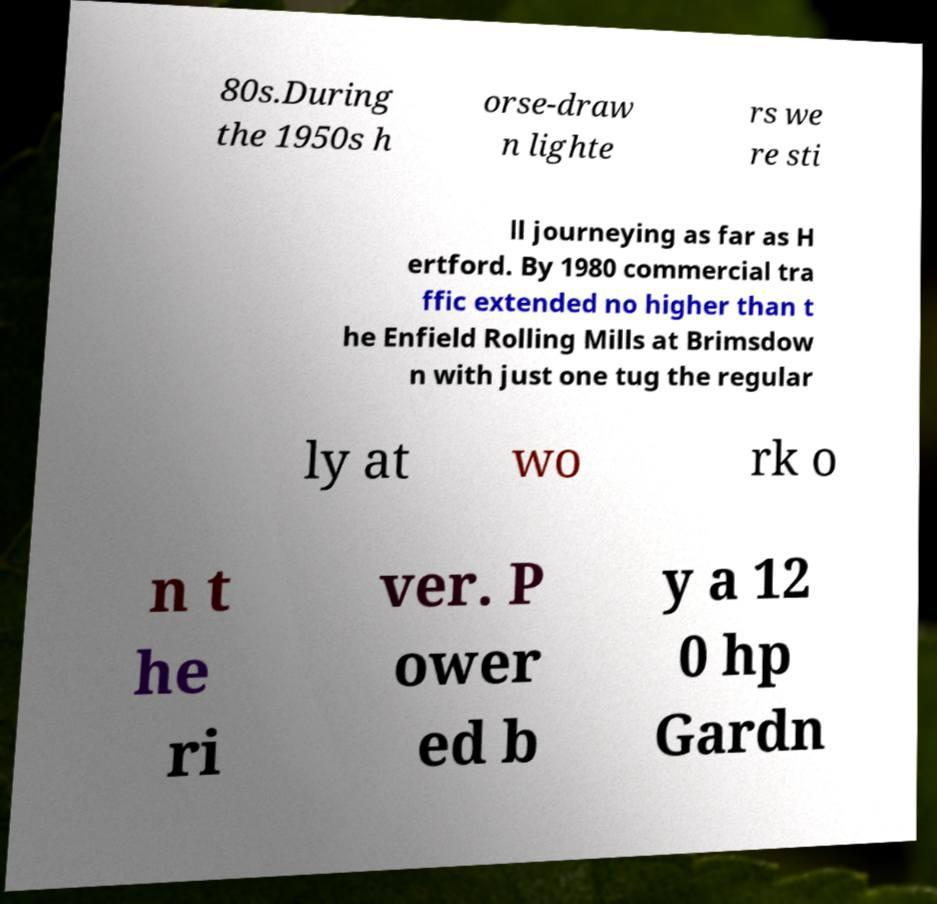What messages or text are displayed in this image? I need them in a readable, typed format. 80s.During the 1950s h orse-draw n lighte rs we re sti ll journeying as far as H ertford. By 1980 commercial tra ffic extended no higher than t he Enfield Rolling Mills at Brimsdow n with just one tug the regular ly at wo rk o n t he ri ver. P ower ed b y a 12 0 hp Gardn 